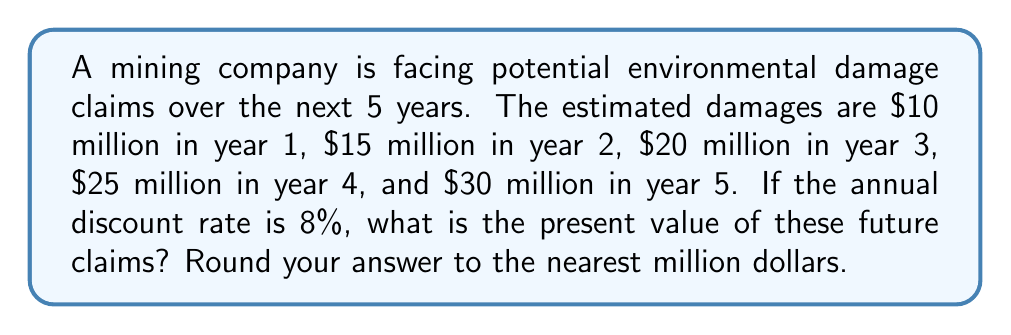Give your solution to this math problem. To calculate the present value of future environmental damage claims, we need to use the present value formula for each year and sum the results. The formula for present value is:

$$ PV = \frac{FV}{(1+r)^n} $$

Where:
PV = Present Value
FV = Future Value
r = Discount rate
n = Number of years

Let's calculate the present value for each year:

Year 1: $PV_1 = \frac{10,000,000}{(1+0.08)^1} = 9,259,259.26$

Year 2: $PV_2 = \frac{15,000,000}{(1+0.08)^2} = 12,860,082.30$

Year 3: $PV_3 = \frac{20,000,000}{(1+0.08)^3} = 15,887,945.41$

Year 4: $PV_4 = \frac{25,000,000}{(1+0.08)^4} = 18,416,683.69$

Year 5: $PV_5 = \frac{30,000,000}{(1+0.08)^5} = 20,462,205.13$

Now, we sum up all the present values:

$$ Total PV = 9,259,259.26 + 12,860,082.30 + 15,887,945.41 + 18,416,683.69 + 20,462,205.13 $$
$$ Total PV = 76,886,175.79 $$

Rounding to the nearest million:

$$ Total PV ≈ 77,000,000 $$
Answer: $77 million 